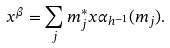Convert formula to latex. <formula><loc_0><loc_0><loc_500><loc_500>x ^ { \beta } = \sum _ { j } m _ { j } ^ { * } x \alpha _ { h ^ { - 1 } } ( m _ { j } ) .</formula> 